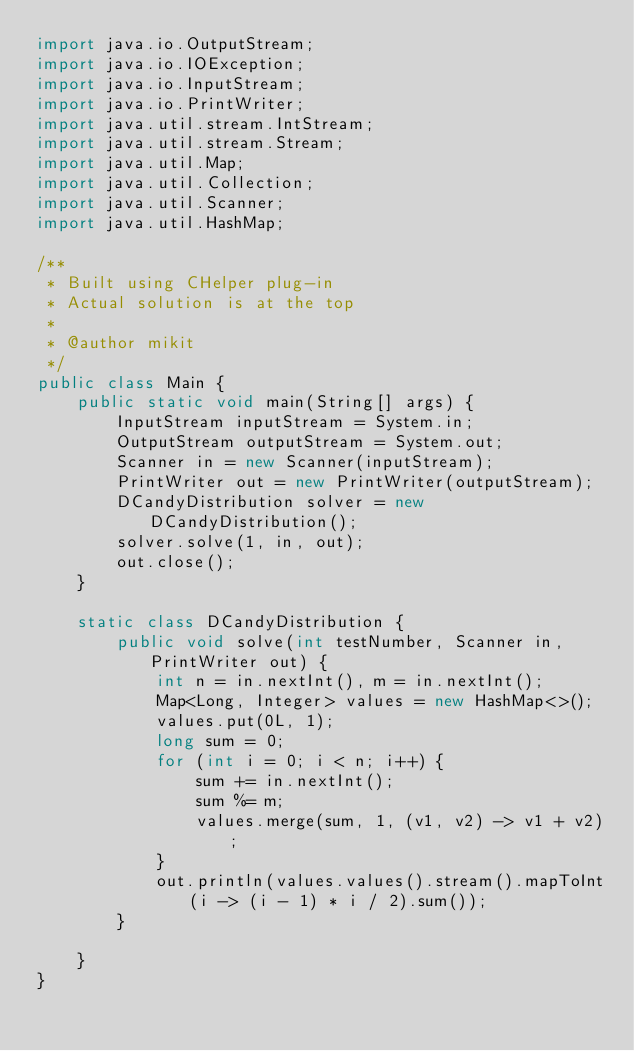Convert code to text. <code><loc_0><loc_0><loc_500><loc_500><_Java_>import java.io.OutputStream;
import java.io.IOException;
import java.io.InputStream;
import java.io.PrintWriter;
import java.util.stream.IntStream;
import java.util.stream.Stream;
import java.util.Map;
import java.util.Collection;
import java.util.Scanner;
import java.util.HashMap;

/**
 * Built using CHelper plug-in
 * Actual solution is at the top
 *
 * @author mikit
 */
public class Main {
    public static void main(String[] args) {
        InputStream inputStream = System.in;
        OutputStream outputStream = System.out;
        Scanner in = new Scanner(inputStream);
        PrintWriter out = new PrintWriter(outputStream);
        DCandyDistribution solver = new DCandyDistribution();
        solver.solve(1, in, out);
        out.close();
    }

    static class DCandyDistribution {
        public void solve(int testNumber, Scanner in, PrintWriter out) {
            int n = in.nextInt(), m = in.nextInt();
            Map<Long, Integer> values = new HashMap<>();
            values.put(0L, 1);
            long sum = 0;
            for (int i = 0; i < n; i++) {
                sum += in.nextInt();
                sum %= m;
                values.merge(sum, 1, (v1, v2) -> v1 + v2);
            }
            out.println(values.values().stream().mapToInt(i -> (i - 1) * i / 2).sum());
        }

    }
}

</code> 